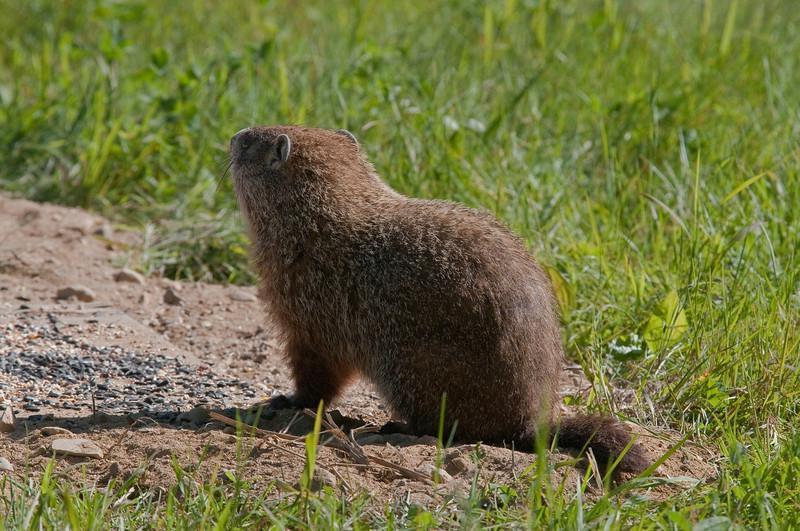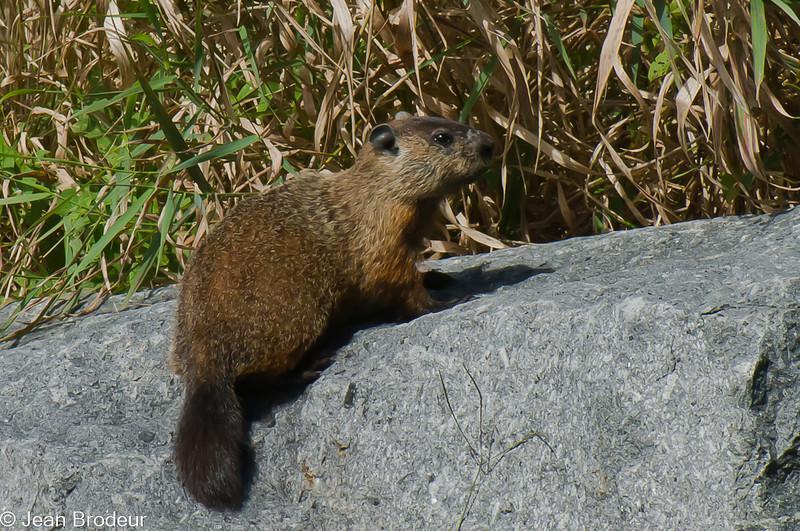The first image is the image on the left, the second image is the image on the right. Evaluate the accuracy of this statement regarding the images: "In one image, an animal is eating.". Is it true? Answer yes or no. No. The first image is the image on the left, the second image is the image on the right. Evaluate the accuracy of this statement regarding the images: "The image on the right shows a single marmot standing on its back legs eating food.". Is it true? Answer yes or no. No. 